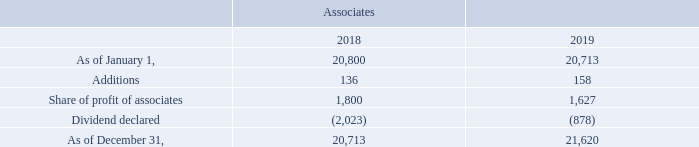GasLog Ltd. and its Subsidiaries Notes to the consolidated financial statements (Continued) For the years ended December 31, 2017, 2018 and 2019 (All amounts expressed in thousands of U.S. Dollars, except share and per share data)      Investment in associates and joint venture consist of the following:
The additions of $158 relate to the investment in Gastrade (December 31, 2018: $136). On February 9, 2017, GasLog acquired a 20% shareholding in Gastrade, a private limited company licensed to develop an independent natural gas system offshore Alexandroupolis in Northern Greece utilizing an FSRU along with other fixed infrastructure. GasLog, as well as being a shareholder, will provide operations and maintenance (‘‘O&M’’) services for the FSRU through an O&M agreement which was signed on February 23, 2018.
How many percent of shareholding in Gastrade did GasLog acquire? 20%. Which country will the development of an independent natural gas system take place? Greece. In which years was the investments recorded for? 2018, 2019. In which year was the dividend declared higher? (2,023) > (878)
Answer: 2018. What was the change in additions from 2018 to 2019?
Answer scale should be: thousand. 158 - 136 
Answer: 22. What was the percentage change in share of profit of associates from 2018 to 2019?
Answer scale should be: percent. (1,627 - 1,800)/1,800 
Answer: -9.61. 